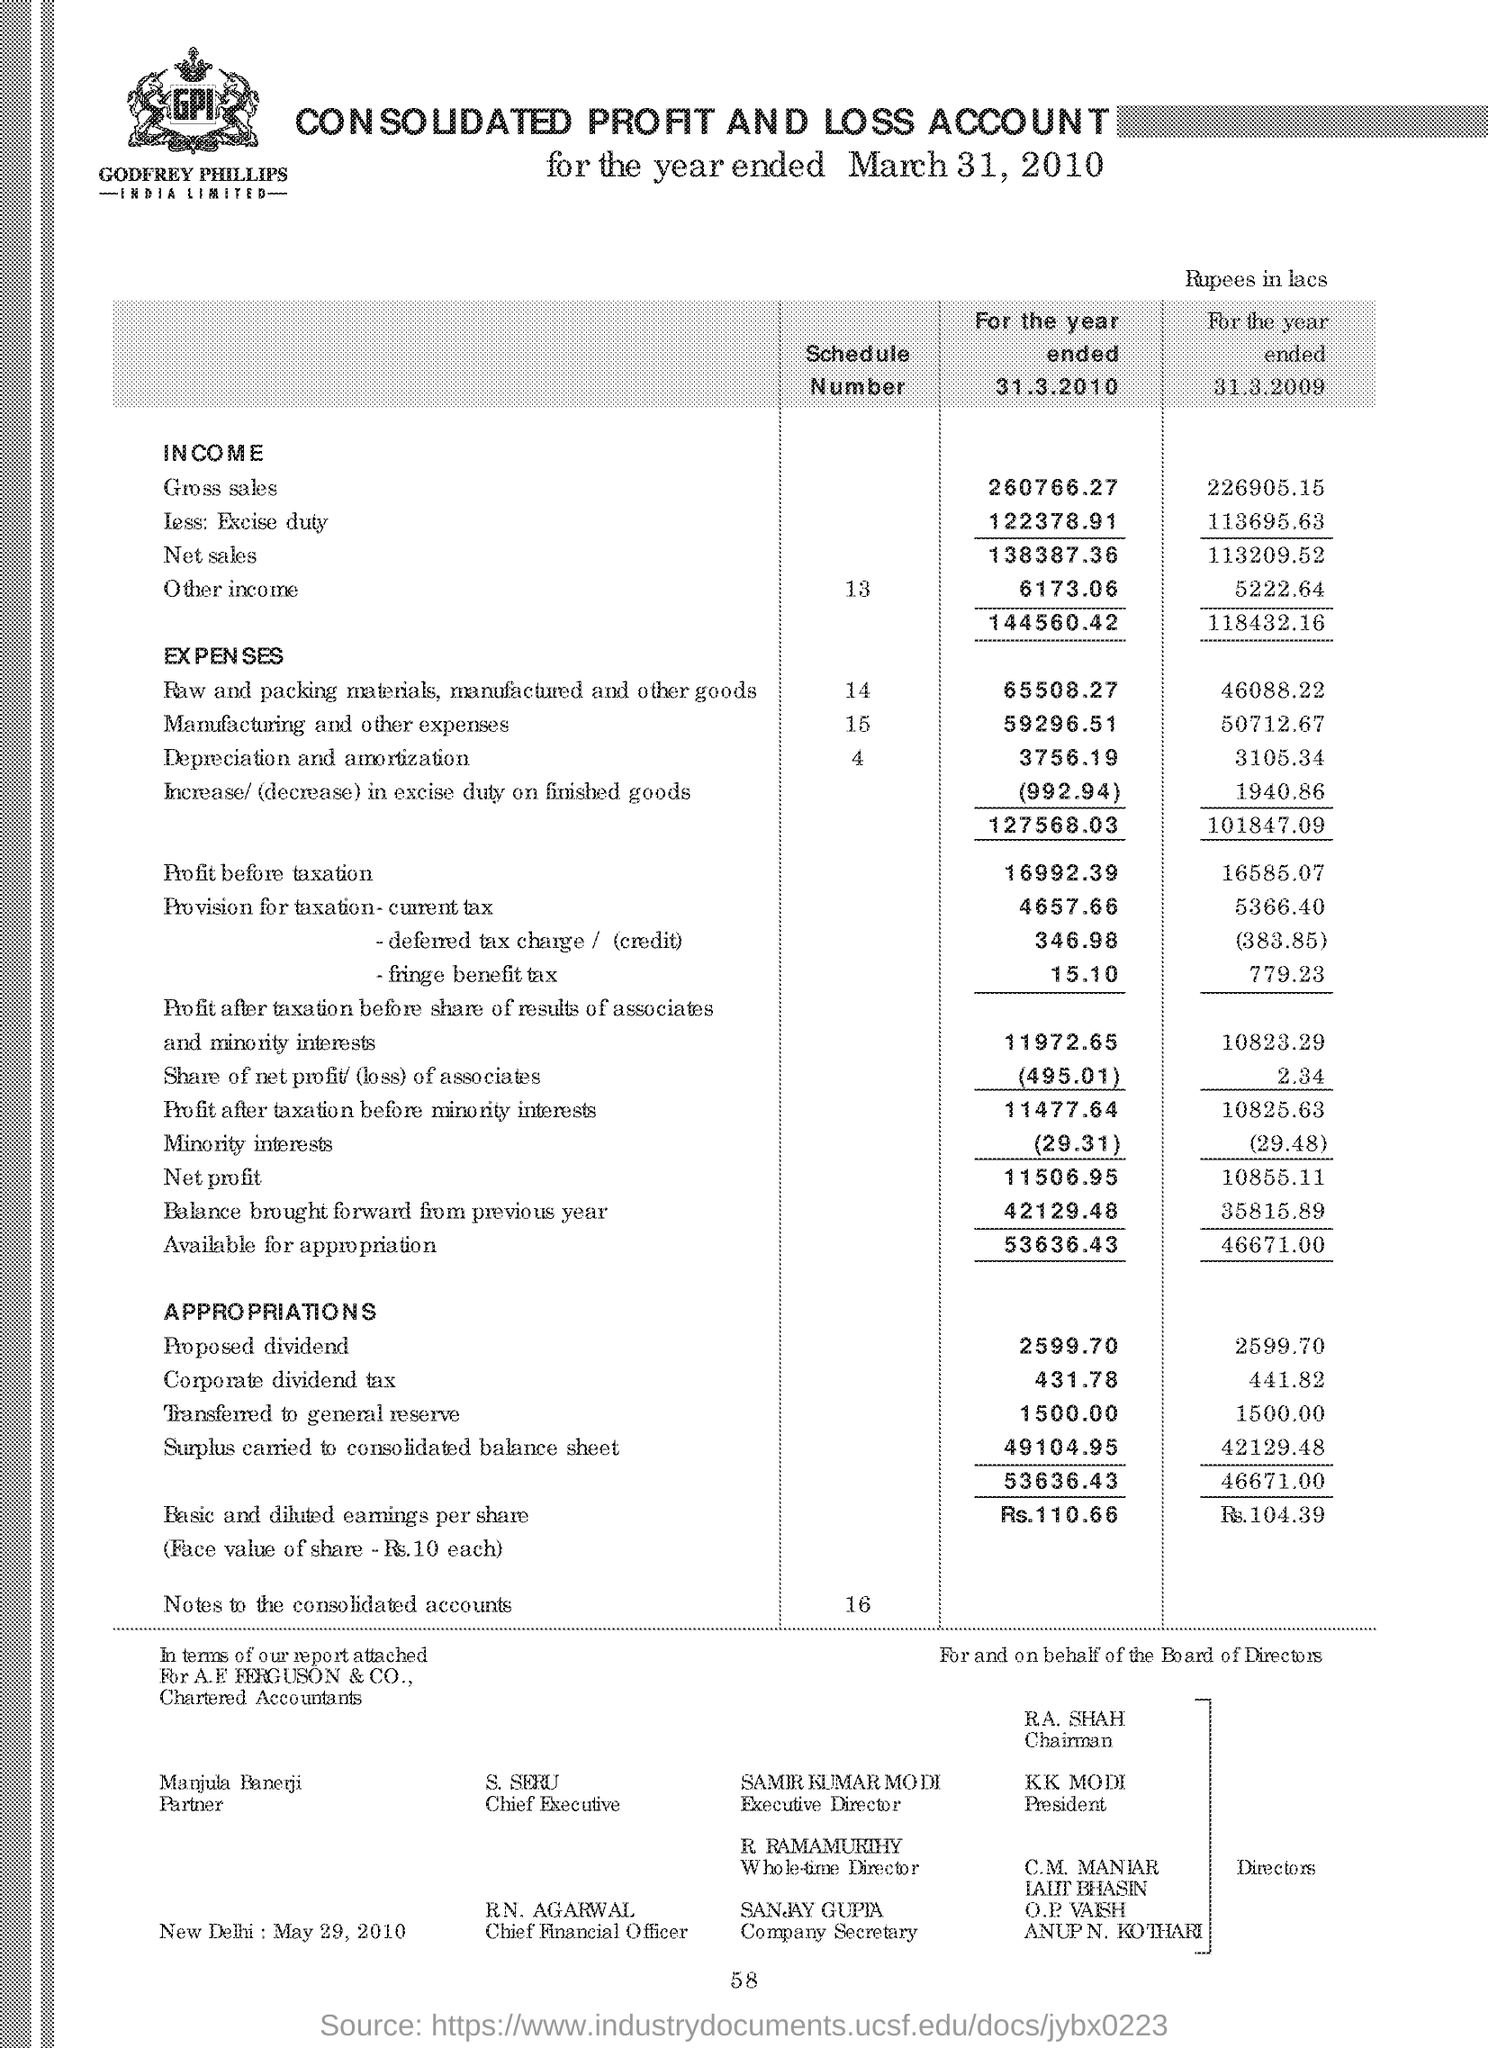What is the schedule number of manufacturing and other expenses as shown in the account ?
Ensure brevity in your answer.  15. Who is the company secretary as shown in the page ?
Provide a short and direct response. SANJAY GUPTA. 